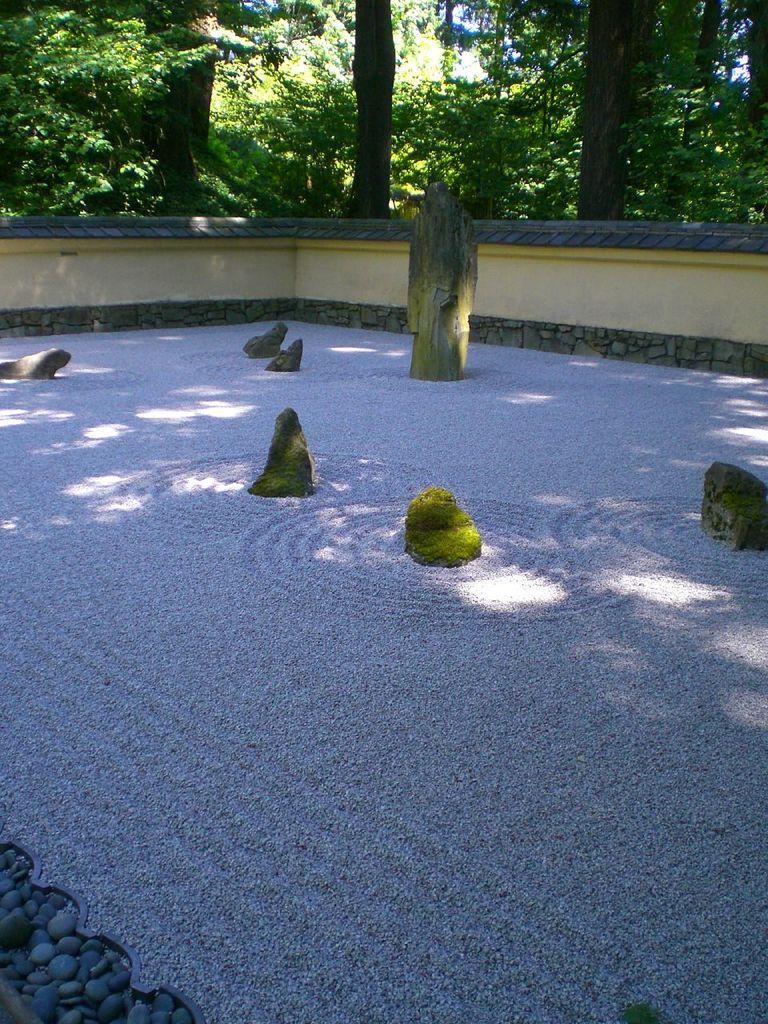How would you summarize this image in a sentence or two? In this image I can see few stones in the centre and in the background I can see number of trees. I can also see shadows on the ground. 